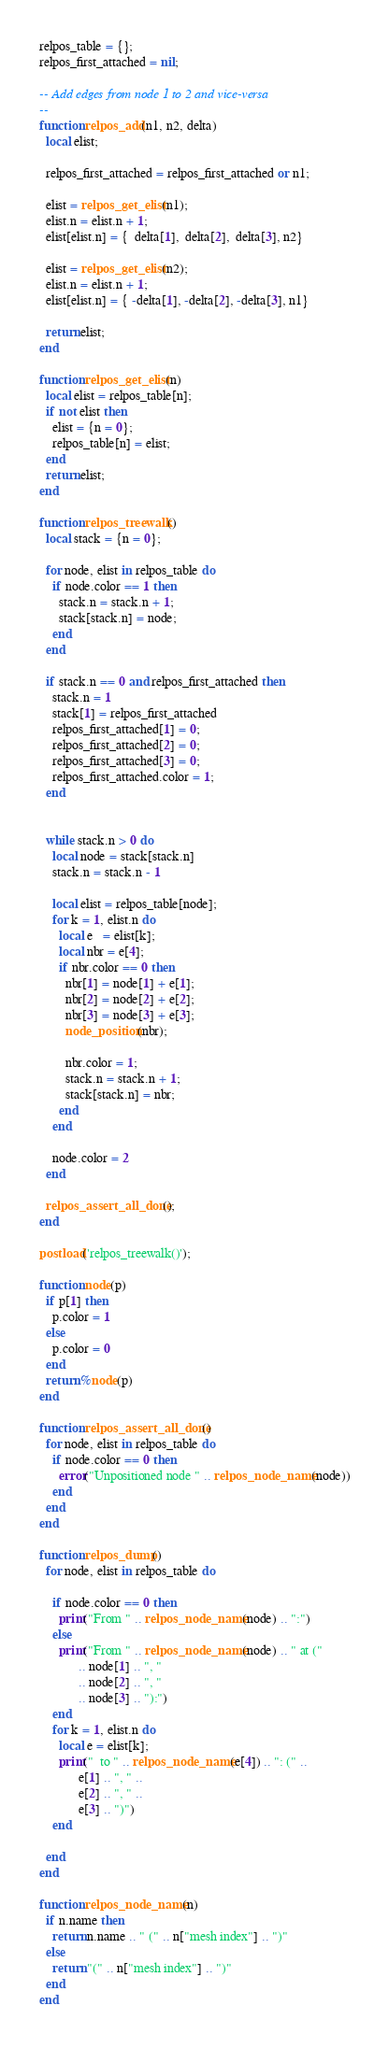<code> <loc_0><loc_0><loc_500><loc_500><_Lua_>relpos_table = {};
relpos_first_attached = nil;

-- Add edges from node 1 to 2 and vice-versa
--
function relpos_add(n1, n2, delta)
  local elist;

  relpos_first_attached = relpos_first_attached or n1;

  elist = relpos_get_elist(n1);
  elist.n = elist.n + 1;
  elist[elist.n] = {  delta[1],  delta[2],  delta[3], n2}

  elist = relpos_get_elist(n2);
  elist.n = elist.n + 1;
  elist[elist.n] = { -delta[1], -delta[2], -delta[3], n1}

  return elist;
end

function relpos_get_elist(n)
  local elist = relpos_table[n];
  if not elist then
    elist = {n = 0};
    relpos_table[n] = elist;
  end
  return elist;
end

function relpos_treewalk()
  local stack = {n = 0};

  for node, elist in relpos_table do
    if node.color == 1 then
      stack.n = stack.n + 1;
      stack[stack.n] = node;
    end
  end
  
  if stack.n == 0 and relpos_first_attached then
    stack.n = 1
    stack[1] = relpos_first_attached
    relpos_first_attached[1] = 0;
    relpos_first_attached[2] = 0;
    relpos_first_attached[3] = 0;
    relpos_first_attached.color = 1;
  end
  

  while stack.n > 0 do
    local node = stack[stack.n]
    stack.n = stack.n - 1

    local elist = relpos_table[node];
    for k = 1, elist.n do
      local e   = elist[k];
      local nbr = e[4]; 
      if nbr.color == 0 then
        nbr[1] = node[1] + e[1];
        nbr[2] = node[2] + e[2];
        nbr[3] = node[3] + e[3];
        node_position(nbr);
        
        nbr.color = 1;
        stack.n = stack.n + 1;
        stack[stack.n] = nbr;
      end
    end

    node.color = 2
  end

  relpos_assert_all_done();
end

postload('relpos_treewalk()');

function node(p)
  if p[1] then
    p.color = 1
  else
    p.color = 0
  end
  return %node(p)
end

function relpos_assert_all_done()
  for node, elist in relpos_table do
    if node.color == 0 then
      error("Unpositioned node " .. relpos_node_name(node))
    end
  end
end

function relpos_dump()
  for node, elist in relpos_table do

    if node.color == 0 then
      print("From " .. relpos_node_name(node) .. ":")
    else
      print("From " .. relpos_node_name(node) .. " at ("
            .. node[1] .. ", "
            .. node[2] .. ", "
            .. node[3] .. "):")
    end
    for k = 1, elist.n do
      local e = elist[k];
      print("  to " .. relpos_node_name(e[4]) .. ": (" ..
            e[1] .. ", " ..
            e[2] .. ", " .. 
            e[3] .. ")")
    end

  end
end

function relpos_node_name(n)
  if n.name then
    return n.name .. " (" .. n["mesh index"] .. ")"
  else
    return "(" .. n["mesh index"] .. ")"
  end
end

</code> 